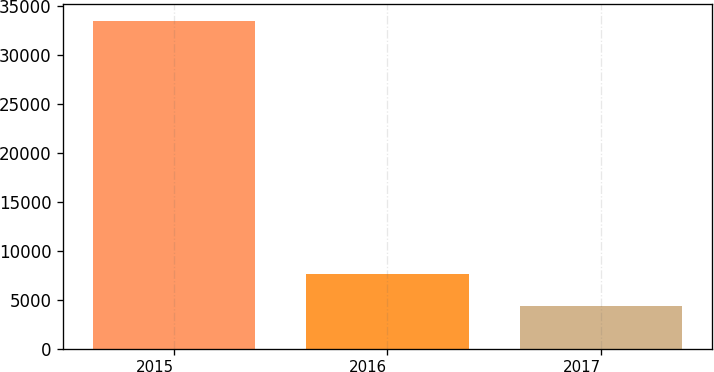Convert chart to OTSL. <chart><loc_0><loc_0><loc_500><loc_500><bar_chart><fcel>2015<fcel>2016<fcel>2017<nl><fcel>33509<fcel>7660<fcel>4317<nl></chart> 